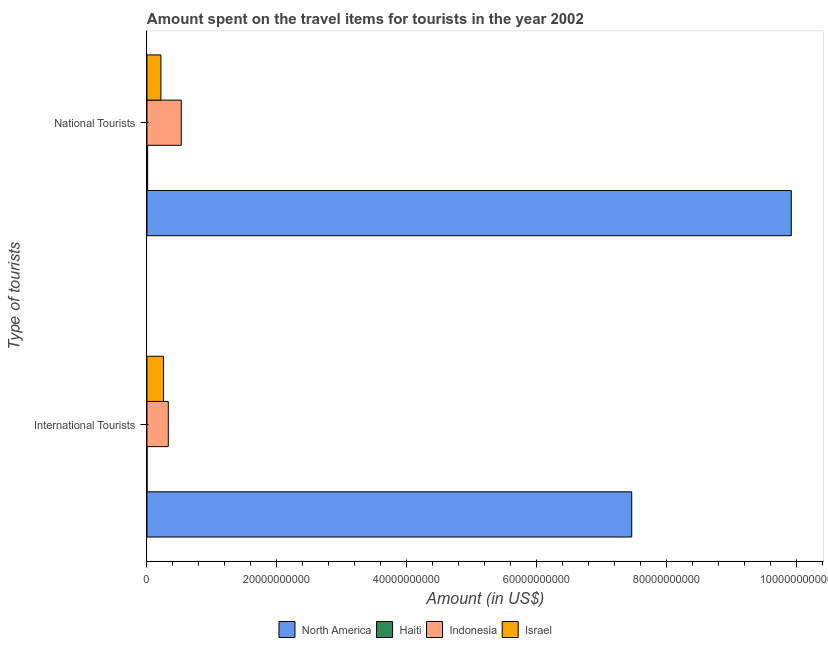Are the number of bars on each tick of the Y-axis equal?
Your response must be concise. Yes. How many bars are there on the 1st tick from the top?
Offer a terse response. 4. How many bars are there on the 2nd tick from the bottom?
Ensure brevity in your answer.  4. What is the label of the 1st group of bars from the top?
Ensure brevity in your answer.  National Tourists. What is the amount spent on travel items of national tourists in Israel?
Offer a very short reply. 2.14e+09. Across all countries, what is the maximum amount spent on travel items of national tourists?
Provide a short and direct response. 9.92e+1. Across all countries, what is the minimum amount spent on travel items of national tourists?
Provide a succinct answer. 1.08e+08. In which country was the amount spent on travel items of national tourists minimum?
Keep it short and to the point. Haiti. What is the total amount spent on travel items of international tourists in the graph?
Your answer should be very brief. 8.05e+1. What is the difference between the amount spent on travel items of national tourists in Israel and that in North America?
Provide a short and direct response. -9.71e+1. What is the difference between the amount spent on travel items of international tourists in Indonesia and the amount spent on travel items of national tourists in Israel?
Your answer should be compact. 1.14e+09. What is the average amount spent on travel items of international tourists per country?
Give a very brief answer. 2.01e+1. What is the difference between the amount spent on travel items of international tourists and amount spent on travel items of national tourists in Haiti?
Offer a very short reply. -9.00e+07. What is the ratio of the amount spent on travel items of international tourists in Israel to that in Indonesia?
Provide a succinct answer. 0.77. Is the amount spent on travel items of international tourists in Indonesia less than that in North America?
Your answer should be very brief. Yes. How many bars are there?
Your answer should be compact. 8. Are all the bars in the graph horizontal?
Ensure brevity in your answer.  Yes. Are the values on the major ticks of X-axis written in scientific E-notation?
Make the answer very short. No. Does the graph contain grids?
Make the answer very short. No. How are the legend labels stacked?
Ensure brevity in your answer.  Horizontal. What is the title of the graph?
Your answer should be very brief. Amount spent on the travel items for tourists in the year 2002. What is the label or title of the X-axis?
Your answer should be very brief. Amount (in US$). What is the label or title of the Y-axis?
Keep it short and to the point. Type of tourists. What is the Amount (in US$) of North America in International Tourists?
Your answer should be very brief. 7.46e+1. What is the Amount (in US$) of Haiti in International Tourists?
Make the answer very short. 1.80e+07. What is the Amount (in US$) of Indonesia in International Tourists?
Your answer should be very brief. 3.29e+09. What is the Amount (in US$) of Israel in International Tourists?
Offer a terse response. 2.54e+09. What is the Amount (in US$) of North America in National Tourists?
Give a very brief answer. 9.92e+1. What is the Amount (in US$) of Haiti in National Tourists?
Your answer should be compact. 1.08e+08. What is the Amount (in US$) of Indonesia in National Tourists?
Give a very brief answer. 5.28e+09. What is the Amount (in US$) of Israel in National Tourists?
Give a very brief answer. 2.14e+09. Across all Type of tourists, what is the maximum Amount (in US$) of North America?
Give a very brief answer. 9.92e+1. Across all Type of tourists, what is the maximum Amount (in US$) of Haiti?
Make the answer very short. 1.08e+08. Across all Type of tourists, what is the maximum Amount (in US$) in Indonesia?
Your answer should be very brief. 5.28e+09. Across all Type of tourists, what is the maximum Amount (in US$) of Israel?
Keep it short and to the point. 2.54e+09. Across all Type of tourists, what is the minimum Amount (in US$) in North America?
Give a very brief answer. 7.46e+1. Across all Type of tourists, what is the minimum Amount (in US$) of Haiti?
Offer a terse response. 1.80e+07. Across all Type of tourists, what is the minimum Amount (in US$) of Indonesia?
Provide a succinct answer. 3.29e+09. Across all Type of tourists, what is the minimum Amount (in US$) of Israel?
Make the answer very short. 2.14e+09. What is the total Amount (in US$) in North America in the graph?
Provide a short and direct response. 1.74e+11. What is the total Amount (in US$) in Haiti in the graph?
Ensure brevity in your answer.  1.26e+08. What is the total Amount (in US$) of Indonesia in the graph?
Offer a very short reply. 8.57e+09. What is the total Amount (in US$) in Israel in the graph?
Make the answer very short. 4.69e+09. What is the difference between the Amount (in US$) in North America in International Tourists and that in National Tourists?
Give a very brief answer. -2.46e+1. What is the difference between the Amount (in US$) in Haiti in International Tourists and that in National Tourists?
Your answer should be very brief. -9.00e+07. What is the difference between the Amount (in US$) in Indonesia in International Tourists and that in National Tourists?
Your response must be concise. -2.00e+09. What is the difference between the Amount (in US$) of Israel in International Tourists and that in National Tourists?
Your answer should be compact. 3.98e+08. What is the difference between the Amount (in US$) in North America in International Tourists and the Amount (in US$) in Haiti in National Tourists?
Ensure brevity in your answer.  7.45e+1. What is the difference between the Amount (in US$) of North America in International Tourists and the Amount (in US$) of Indonesia in National Tourists?
Offer a terse response. 6.94e+1. What is the difference between the Amount (in US$) of North America in International Tourists and the Amount (in US$) of Israel in National Tourists?
Offer a terse response. 7.25e+1. What is the difference between the Amount (in US$) in Haiti in International Tourists and the Amount (in US$) in Indonesia in National Tourists?
Offer a terse response. -5.27e+09. What is the difference between the Amount (in US$) of Haiti in International Tourists and the Amount (in US$) of Israel in National Tourists?
Your response must be concise. -2.13e+09. What is the difference between the Amount (in US$) of Indonesia in International Tourists and the Amount (in US$) of Israel in National Tourists?
Make the answer very short. 1.14e+09. What is the average Amount (in US$) in North America per Type of tourists?
Provide a short and direct response. 8.69e+1. What is the average Amount (in US$) of Haiti per Type of tourists?
Ensure brevity in your answer.  6.30e+07. What is the average Amount (in US$) in Indonesia per Type of tourists?
Your answer should be compact. 4.29e+09. What is the average Amount (in US$) in Israel per Type of tourists?
Provide a short and direct response. 2.34e+09. What is the difference between the Amount (in US$) in North America and Amount (in US$) in Haiti in International Tourists?
Give a very brief answer. 7.46e+1. What is the difference between the Amount (in US$) of North America and Amount (in US$) of Indonesia in International Tourists?
Offer a terse response. 7.13e+1. What is the difference between the Amount (in US$) of North America and Amount (in US$) of Israel in International Tourists?
Give a very brief answer. 7.21e+1. What is the difference between the Amount (in US$) of Haiti and Amount (in US$) of Indonesia in International Tourists?
Ensure brevity in your answer.  -3.27e+09. What is the difference between the Amount (in US$) in Haiti and Amount (in US$) in Israel in International Tourists?
Offer a very short reply. -2.52e+09. What is the difference between the Amount (in US$) in Indonesia and Amount (in US$) in Israel in International Tourists?
Offer a very short reply. 7.46e+08. What is the difference between the Amount (in US$) in North America and Amount (in US$) in Haiti in National Tourists?
Provide a short and direct response. 9.91e+1. What is the difference between the Amount (in US$) in North America and Amount (in US$) in Indonesia in National Tourists?
Give a very brief answer. 9.39e+1. What is the difference between the Amount (in US$) of North America and Amount (in US$) of Israel in National Tourists?
Your answer should be very brief. 9.71e+1. What is the difference between the Amount (in US$) in Haiti and Amount (in US$) in Indonesia in National Tourists?
Give a very brief answer. -5.18e+09. What is the difference between the Amount (in US$) in Haiti and Amount (in US$) in Israel in National Tourists?
Ensure brevity in your answer.  -2.04e+09. What is the difference between the Amount (in US$) in Indonesia and Amount (in US$) in Israel in National Tourists?
Keep it short and to the point. 3.14e+09. What is the ratio of the Amount (in US$) in North America in International Tourists to that in National Tourists?
Offer a very short reply. 0.75. What is the ratio of the Amount (in US$) in Indonesia in International Tourists to that in National Tourists?
Make the answer very short. 0.62. What is the ratio of the Amount (in US$) in Israel in International Tourists to that in National Tourists?
Make the answer very short. 1.19. What is the difference between the highest and the second highest Amount (in US$) of North America?
Keep it short and to the point. 2.46e+1. What is the difference between the highest and the second highest Amount (in US$) in Haiti?
Make the answer very short. 9.00e+07. What is the difference between the highest and the second highest Amount (in US$) of Indonesia?
Keep it short and to the point. 2.00e+09. What is the difference between the highest and the second highest Amount (in US$) in Israel?
Ensure brevity in your answer.  3.98e+08. What is the difference between the highest and the lowest Amount (in US$) of North America?
Offer a very short reply. 2.46e+1. What is the difference between the highest and the lowest Amount (in US$) in Haiti?
Provide a succinct answer. 9.00e+07. What is the difference between the highest and the lowest Amount (in US$) of Indonesia?
Your answer should be compact. 2.00e+09. What is the difference between the highest and the lowest Amount (in US$) in Israel?
Make the answer very short. 3.98e+08. 